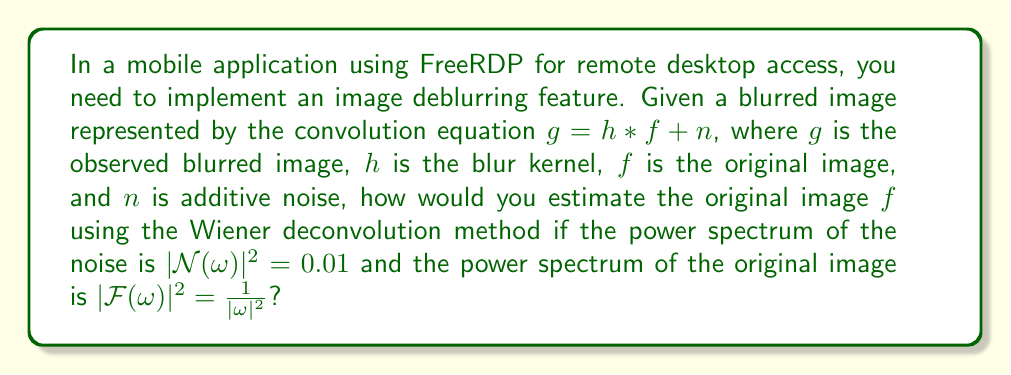Teach me how to tackle this problem. To estimate the original image using Wiener deconvolution, we follow these steps:

1. The Wiener deconvolution filter in the frequency domain is given by:

   $$W(\omega) = \frac{H^*(\omega)}{|H(\omega)|^2 + \frac{|\mathcal{N}(\omega)|^2}{|\mathcal{F}(\omega)|^2}}$$

   where $H(\omega)$ is the Fourier transform of the blur kernel $h$, and $H^*(\omega)$ is its complex conjugate.

2. Substitute the given values:
   $|\mathcal{N}(\omega)|^2 = 0.01$
   $|\mathcal{F}(\omega)|^2 = \frac{1}{|\omega|^2}$

3. The Wiener filter becomes:

   $$W(\omega) = \frac{H^*(\omega)}{|H(\omega)|^2 + 0.01|\omega|^2}$$

4. To estimate the original image, apply the Wiener filter to the Fourier transform of the blurred image:

   $$\hat{F}(\omega) = W(\omega)G(\omega)$$

   where $G(\omega)$ is the Fourier transform of the blurred image $g$.

5. The estimated original image $\hat{f}$ is obtained by taking the inverse Fourier transform of $\hat{F}(\omega)$:

   $$\hat{f} = \mathcal{F}^{-1}[\hat{F}(\omega)]$$

In the context of Android development using FreeRDP, you would implement this algorithm using libraries like OpenCV or custom image processing functions, applying the Wiener filter in the frequency domain and then converting the result back to the spatial domain.
Answer: $\hat{f} = \mathcal{F}^{-1}[\frac{H^*(\omega)}{|H(\omega)|^2 + 0.01|\omega|^2}G(\omega)]$ 